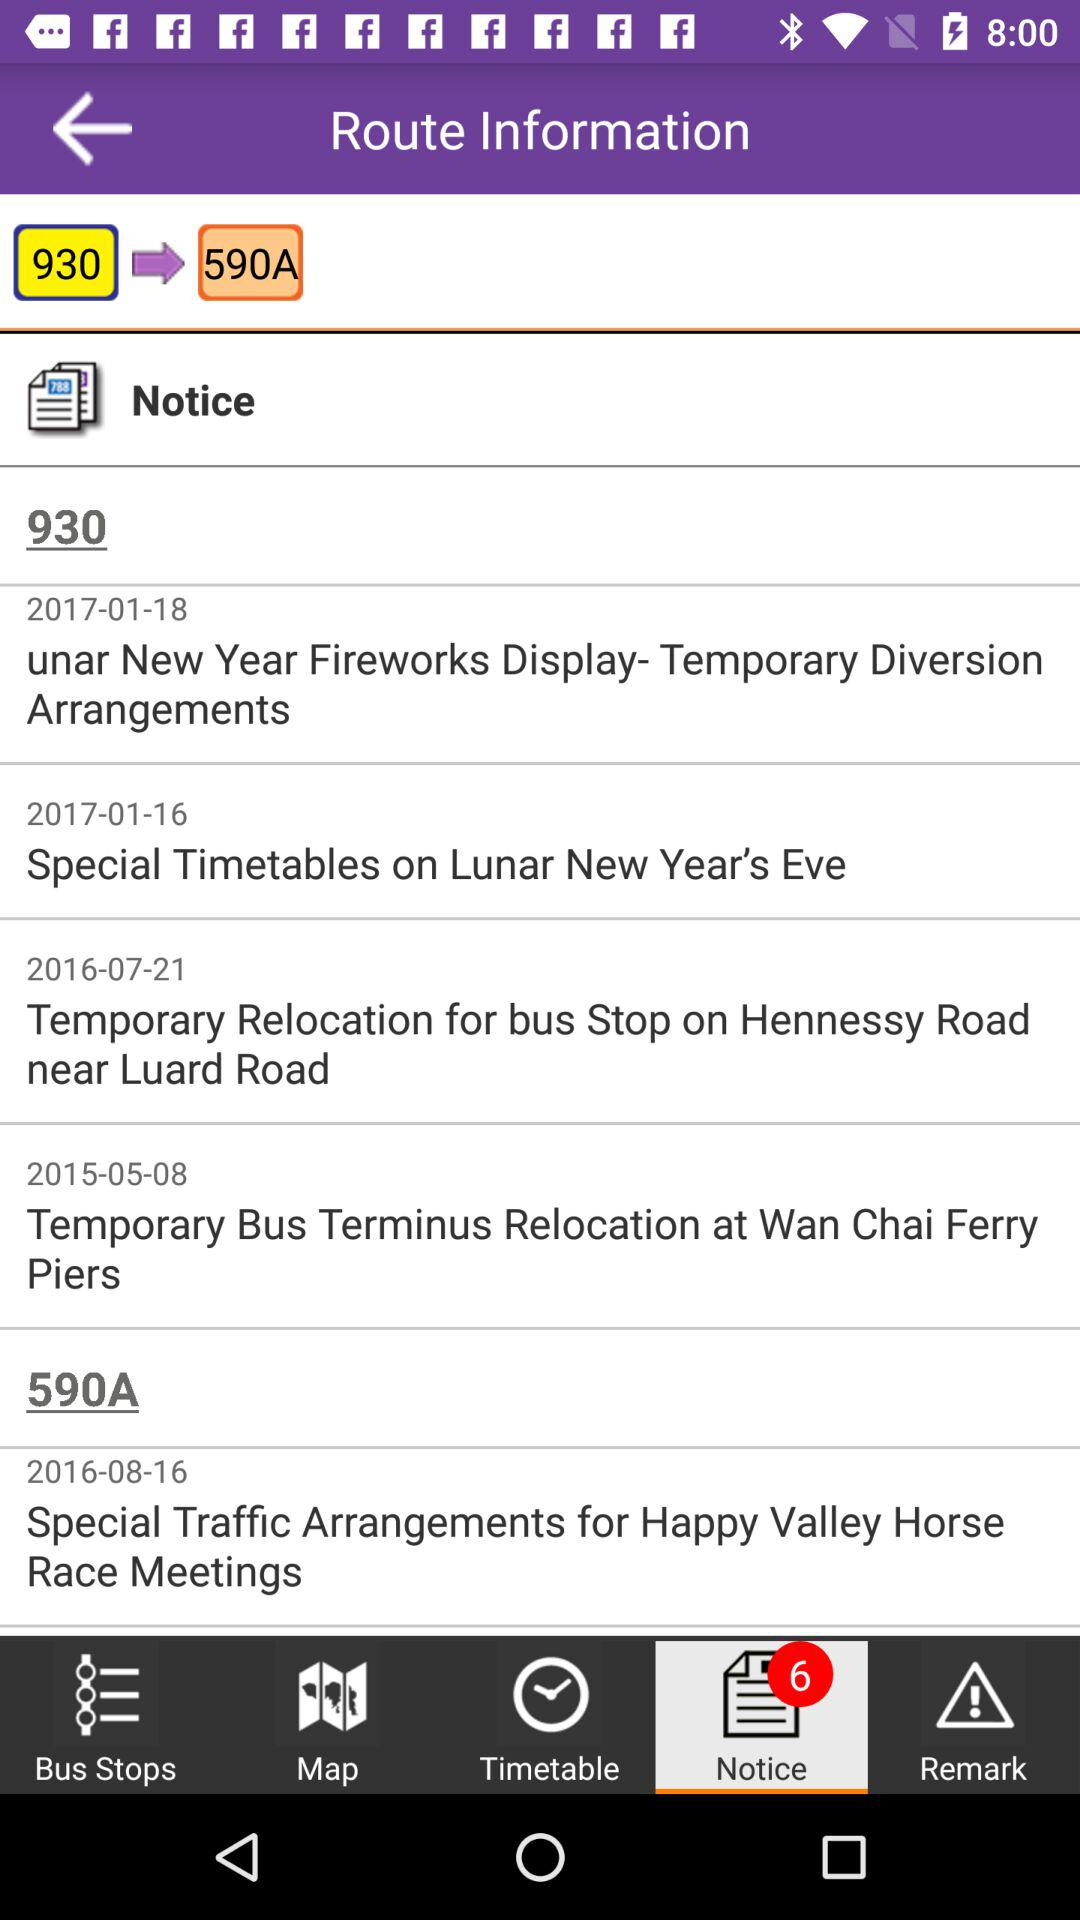What are the route numbers? The route numbers are 930 and 590A. 